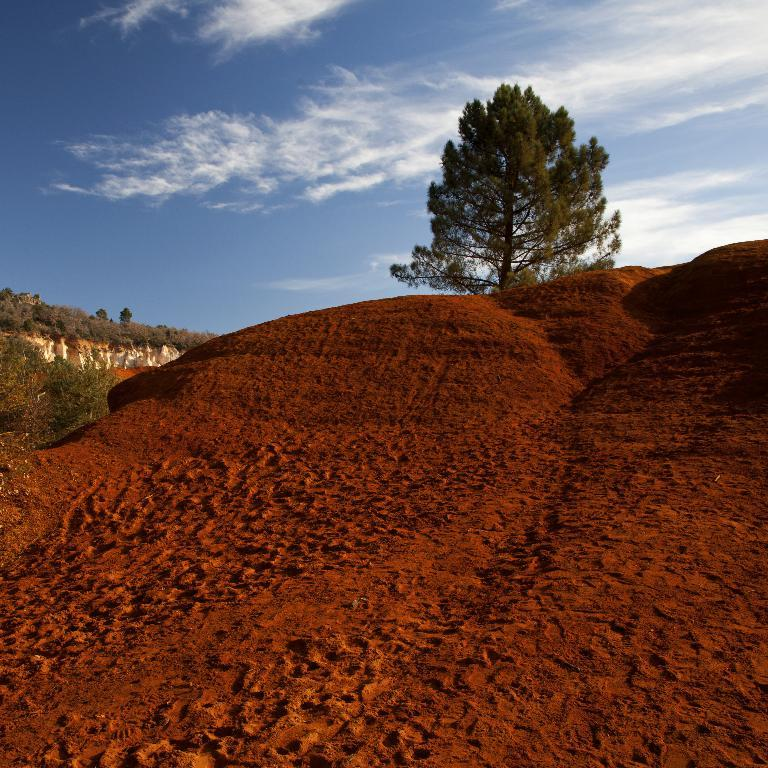What type of terrain is visible in the image? There is sand in the image. What other natural elements can be seen in the image? There are plants and trees in the image. What is visible at the top of the image? The sky is visible at the top of the image. What can be observed in the sky? Clouds are present in the sky. How much wealth is buried in the sand in the image? There is no indication of wealth or any buried objects in the image; it simply shows sand, plants, trees, and a sky with clouds. 